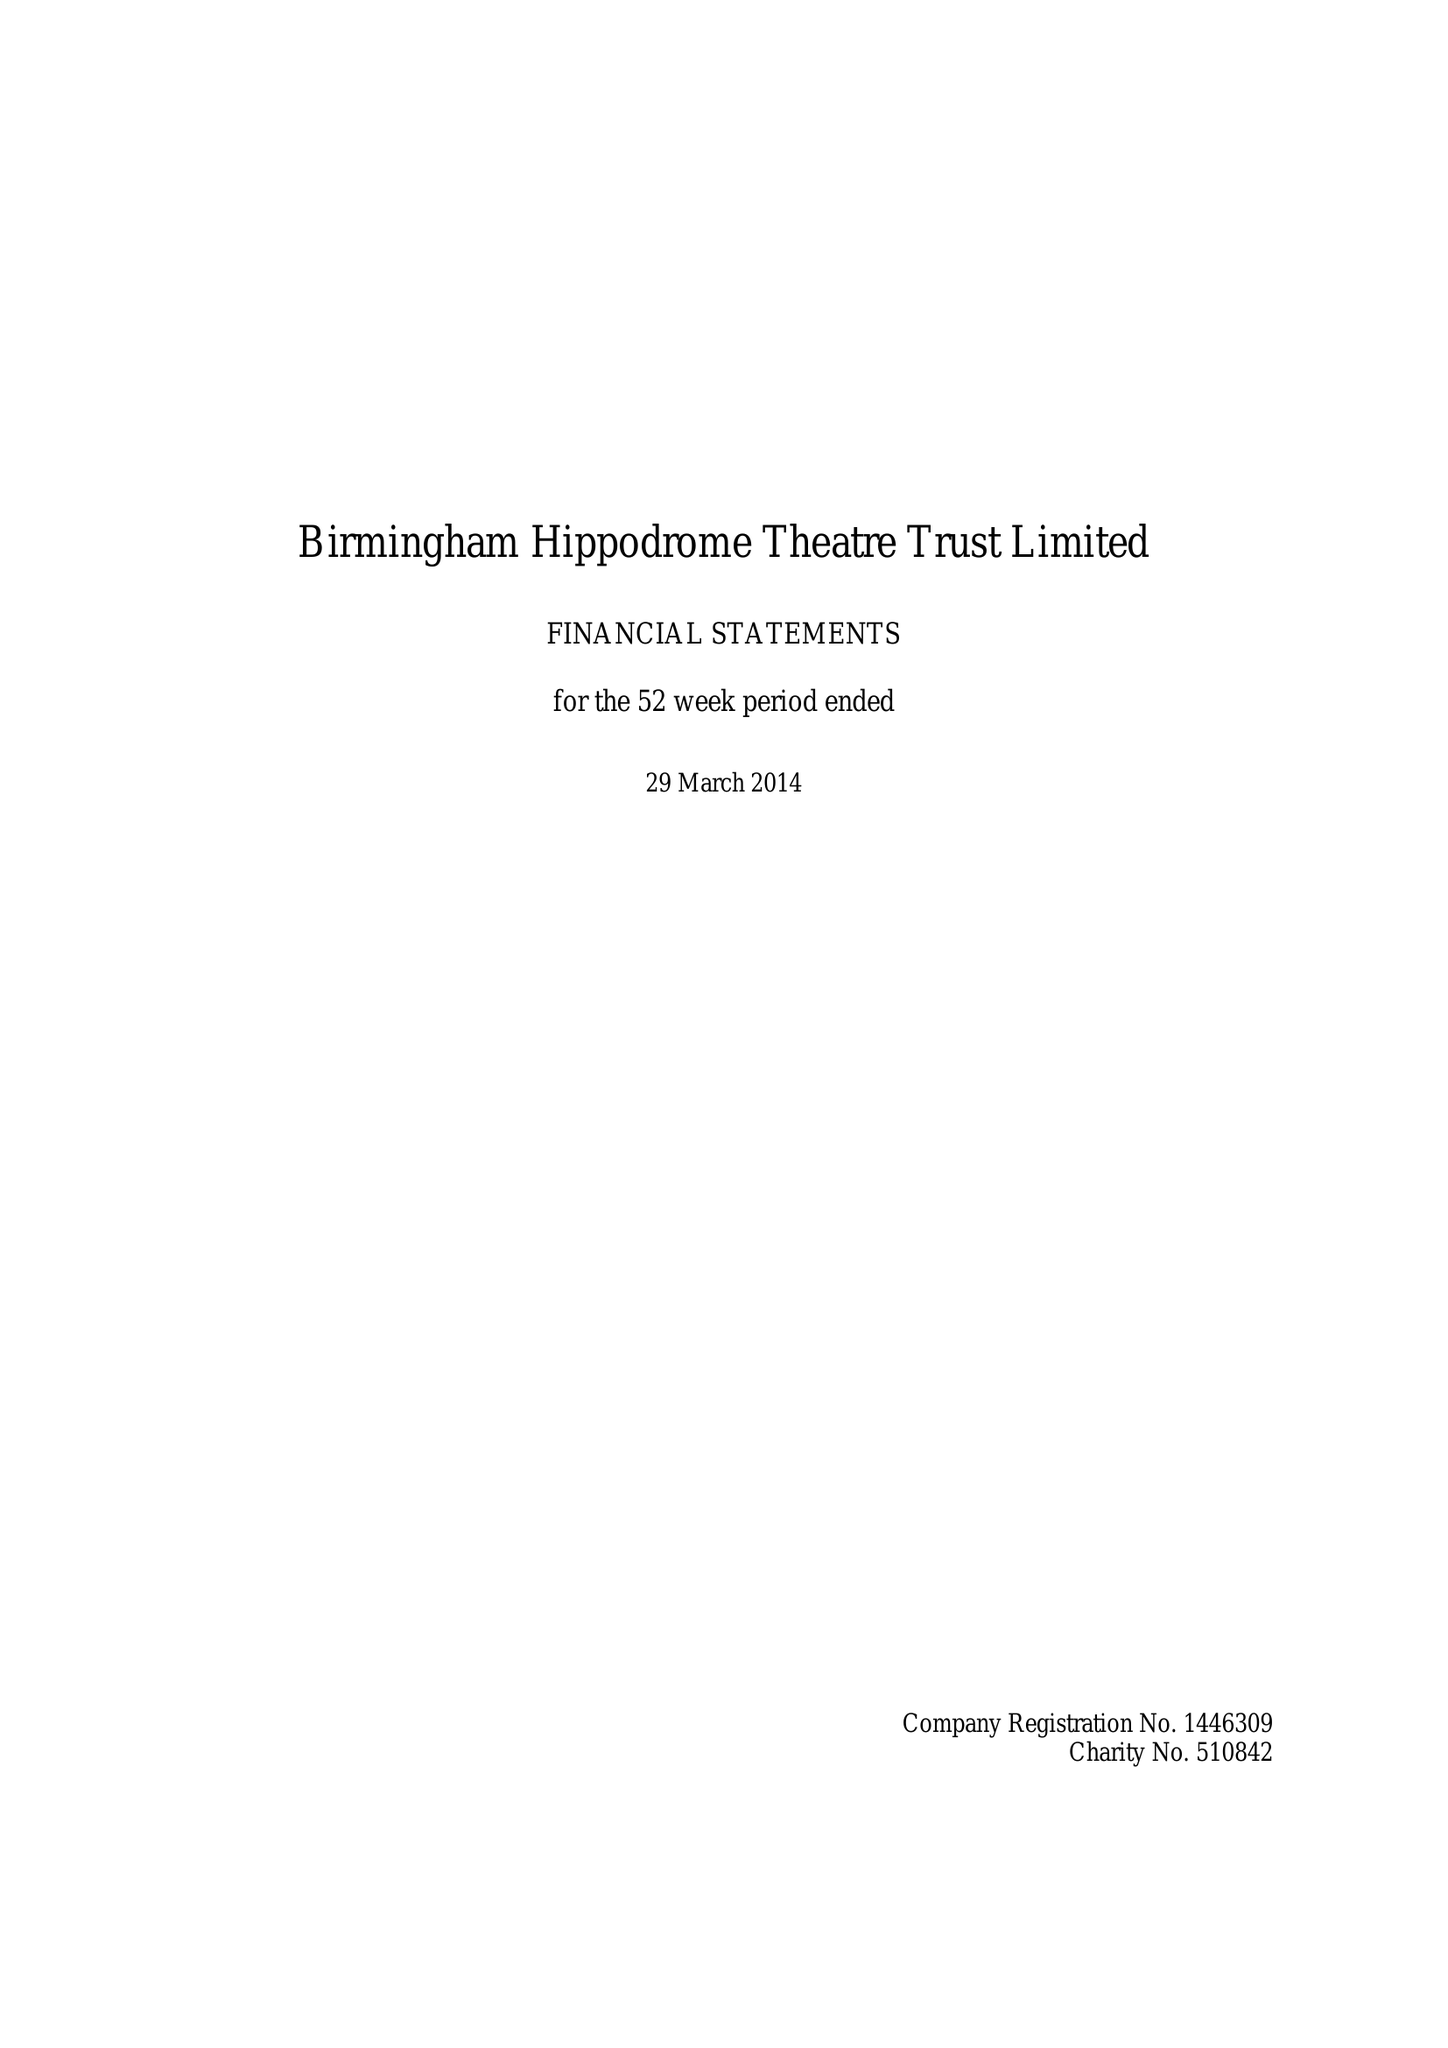What is the value for the address__post_town?
Answer the question using a single word or phrase. BIRMINGHAM 